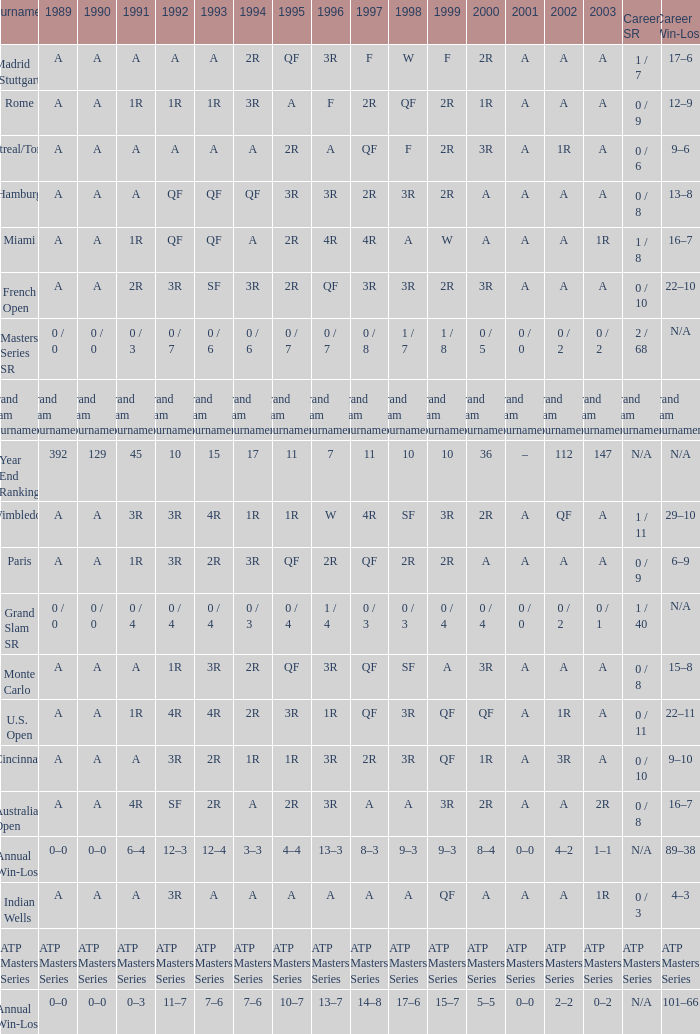What was the value in 1995 for A in 2000 at the Indian Wells tournament? A. 